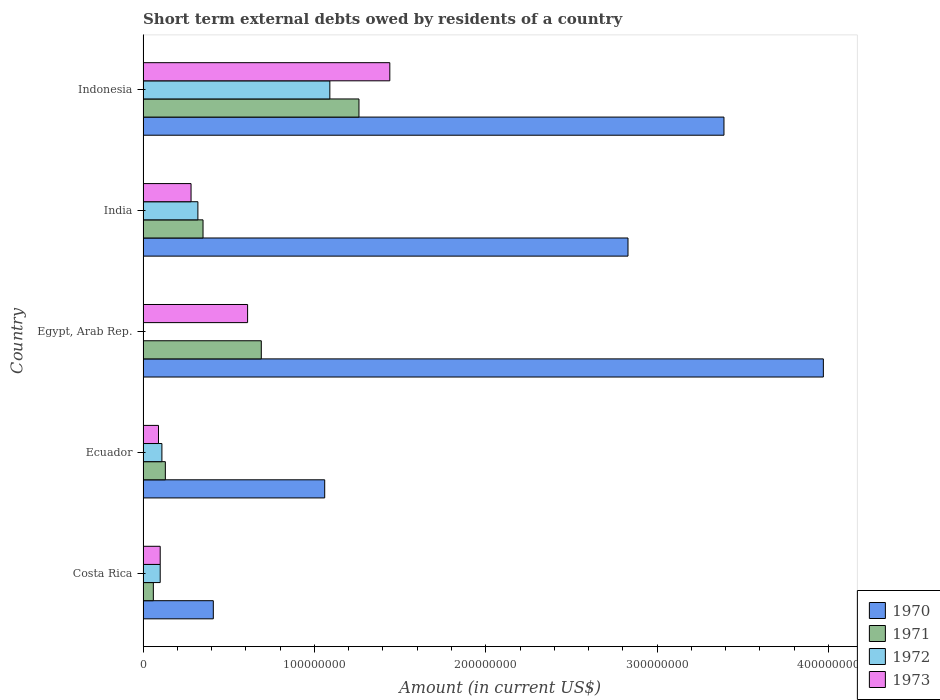How many groups of bars are there?
Offer a very short reply. 5. Are the number of bars on each tick of the Y-axis equal?
Give a very brief answer. No. How many bars are there on the 5th tick from the bottom?
Your answer should be compact. 4. What is the label of the 3rd group of bars from the top?
Ensure brevity in your answer.  Egypt, Arab Rep. What is the amount of short-term external debts owed by residents in 1973 in Egypt, Arab Rep.?
Your response must be concise. 6.10e+07. Across all countries, what is the maximum amount of short-term external debts owed by residents in 1971?
Ensure brevity in your answer.  1.26e+08. What is the total amount of short-term external debts owed by residents in 1970 in the graph?
Provide a succinct answer. 1.17e+09. What is the difference between the amount of short-term external debts owed by residents in 1972 in Costa Rica and that in Ecuador?
Provide a succinct answer. -1.00e+06. What is the difference between the amount of short-term external debts owed by residents in 1971 in India and the amount of short-term external debts owed by residents in 1972 in Ecuador?
Offer a very short reply. 2.40e+07. What is the average amount of short-term external debts owed by residents in 1970 per country?
Make the answer very short. 2.33e+08. What is the difference between the amount of short-term external debts owed by residents in 1973 and amount of short-term external debts owed by residents in 1970 in Egypt, Arab Rep.?
Offer a very short reply. -3.36e+08. In how many countries, is the amount of short-term external debts owed by residents in 1972 greater than 220000000 US$?
Your answer should be very brief. 0. What is the ratio of the amount of short-term external debts owed by residents in 1970 in Costa Rica to that in Ecuador?
Keep it short and to the point. 0.39. Is the difference between the amount of short-term external debts owed by residents in 1973 in Ecuador and India greater than the difference between the amount of short-term external debts owed by residents in 1970 in Ecuador and India?
Your answer should be compact. Yes. What is the difference between the highest and the second highest amount of short-term external debts owed by residents in 1970?
Give a very brief answer. 5.80e+07. What is the difference between the highest and the lowest amount of short-term external debts owed by residents in 1970?
Offer a terse response. 3.56e+08. In how many countries, is the amount of short-term external debts owed by residents in 1972 greater than the average amount of short-term external debts owed by residents in 1972 taken over all countries?
Give a very brief answer. 1. Is the sum of the amount of short-term external debts owed by residents in 1971 in Costa Rica and India greater than the maximum amount of short-term external debts owed by residents in 1970 across all countries?
Give a very brief answer. No. Is it the case that in every country, the sum of the amount of short-term external debts owed by residents in 1971 and amount of short-term external debts owed by residents in 1970 is greater than the sum of amount of short-term external debts owed by residents in 1972 and amount of short-term external debts owed by residents in 1973?
Give a very brief answer. No. Is it the case that in every country, the sum of the amount of short-term external debts owed by residents in 1973 and amount of short-term external debts owed by residents in 1970 is greater than the amount of short-term external debts owed by residents in 1971?
Keep it short and to the point. Yes. How many bars are there?
Your answer should be compact. 19. Are all the bars in the graph horizontal?
Your response must be concise. Yes. What is the difference between two consecutive major ticks on the X-axis?
Your answer should be very brief. 1.00e+08. Are the values on the major ticks of X-axis written in scientific E-notation?
Keep it short and to the point. No. Does the graph contain grids?
Make the answer very short. No. Where does the legend appear in the graph?
Ensure brevity in your answer.  Bottom right. How are the legend labels stacked?
Offer a very short reply. Vertical. What is the title of the graph?
Ensure brevity in your answer.  Short term external debts owed by residents of a country. What is the label or title of the Y-axis?
Your answer should be very brief. Country. What is the Amount (in current US$) of 1970 in Costa Rica?
Offer a very short reply. 4.10e+07. What is the Amount (in current US$) in 1972 in Costa Rica?
Offer a terse response. 1.00e+07. What is the Amount (in current US$) in 1970 in Ecuador?
Ensure brevity in your answer.  1.06e+08. What is the Amount (in current US$) in 1971 in Ecuador?
Your response must be concise. 1.30e+07. What is the Amount (in current US$) of 1972 in Ecuador?
Make the answer very short. 1.10e+07. What is the Amount (in current US$) of 1973 in Ecuador?
Ensure brevity in your answer.  9.00e+06. What is the Amount (in current US$) in 1970 in Egypt, Arab Rep.?
Your answer should be compact. 3.97e+08. What is the Amount (in current US$) of 1971 in Egypt, Arab Rep.?
Make the answer very short. 6.90e+07. What is the Amount (in current US$) in 1973 in Egypt, Arab Rep.?
Provide a short and direct response. 6.10e+07. What is the Amount (in current US$) in 1970 in India?
Provide a succinct answer. 2.83e+08. What is the Amount (in current US$) of 1971 in India?
Your answer should be compact. 3.50e+07. What is the Amount (in current US$) of 1972 in India?
Give a very brief answer. 3.20e+07. What is the Amount (in current US$) in 1973 in India?
Make the answer very short. 2.80e+07. What is the Amount (in current US$) of 1970 in Indonesia?
Offer a terse response. 3.39e+08. What is the Amount (in current US$) of 1971 in Indonesia?
Ensure brevity in your answer.  1.26e+08. What is the Amount (in current US$) of 1972 in Indonesia?
Your answer should be compact. 1.09e+08. What is the Amount (in current US$) in 1973 in Indonesia?
Your response must be concise. 1.44e+08. Across all countries, what is the maximum Amount (in current US$) of 1970?
Your response must be concise. 3.97e+08. Across all countries, what is the maximum Amount (in current US$) in 1971?
Provide a short and direct response. 1.26e+08. Across all countries, what is the maximum Amount (in current US$) of 1972?
Provide a succinct answer. 1.09e+08. Across all countries, what is the maximum Amount (in current US$) in 1973?
Offer a very short reply. 1.44e+08. Across all countries, what is the minimum Amount (in current US$) of 1970?
Provide a succinct answer. 4.10e+07. Across all countries, what is the minimum Amount (in current US$) of 1971?
Offer a terse response. 6.00e+06. Across all countries, what is the minimum Amount (in current US$) in 1972?
Keep it short and to the point. 0. Across all countries, what is the minimum Amount (in current US$) in 1973?
Keep it short and to the point. 9.00e+06. What is the total Amount (in current US$) in 1970 in the graph?
Your answer should be very brief. 1.17e+09. What is the total Amount (in current US$) in 1971 in the graph?
Make the answer very short. 2.49e+08. What is the total Amount (in current US$) of 1972 in the graph?
Your answer should be very brief. 1.62e+08. What is the total Amount (in current US$) in 1973 in the graph?
Your answer should be compact. 2.52e+08. What is the difference between the Amount (in current US$) in 1970 in Costa Rica and that in Ecuador?
Offer a very short reply. -6.50e+07. What is the difference between the Amount (in current US$) of 1971 in Costa Rica and that in Ecuador?
Keep it short and to the point. -7.00e+06. What is the difference between the Amount (in current US$) of 1970 in Costa Rica and that in Egypt, Arab Rep.?
Ensure brevity in your answer.  -3.56e+08. What is the difference between the Amount (in current US$) of 1971 in Costa Rica and that in Egypt, Arab Rep.?
Your response must be concise. -6.30e+07. What is the difference between the Amount (in current US$) in 1973 in Costa Rica and that in Egypt, Arab Rep.?
Give a very brief answer. -5.10e+07. What is the difference between the Amount (in current US$) in 1970 in Costa Rica and that in India?
Your answer should be compact. -2.42e+08. What is the difference between the Amount (in current US$) in 1971 in Costa Rica and that in India?
Make the answer very short. -2.90e+07. What is the difference between the Amount (in current US$) of 1972 in Costa Rica and that in India?
Make the answer very short. -2.20e+07. What is the difference between the Amount (in current US$) in 1973 in Costa Rica and that in India?
Your response must be concise. -1.80e+07. What is the difference between the Amount (in current US$) of 1970 in Costa Rica and that in Indonesia?
Provide a short and direct response. -2.98e+08. What is the difference between the Amount (in current US$) in 1971 in Costa Rica and that in Indonesia?
Give a very brief answer. -1.20e+08. What is the difference between the Amount (in current US$) in 1972 in Costa Rica and that in Indonesia?
Provide a succinct answer. -9.90e+07. What is the difference between the Amount (in current US$) of 1973 in Costa Rica and that in Indonesia?
Give a very brief answer. -1.34e+08. What is the difference between the Amount (in current US$) of 1970 in Ecuador and that in Egypt, Arab Rep.?
Make the answer very short. -2.91e+08. What is the difference between the Amount (in current US$) in 1971 in Ecuador and that in Egypt, Arab Rep.?
Provide a short and direct response. -5.60e+07. What is the difference between the Amount (in current US$) of 1973 in Ecuador and that in Egypt, Arab Rep.?
Give a very brief answer. -5.20e+07. What is the difference between the Amount (in current US$) in 1970 in Ecuador and that in India?
Give a very brief answer. -1.77e+08. What is the difference between the Amount (in current US$) of 1971 in Ecuador and that in India?
Provide a succinct answer. -2.20e+07. What is the difference between the Amount (in current US$) in 1972 in Ecuador and that in India?
Your response must be concise. -2.10e+07. What is the difference between the Amount (in current US$) of 1973 in Ecuador and that in India?
Your answer should be very brief. -1.90e+07. What is the difference between the Amount (in current US$) of 1970 in Ecuador and that in Indonesia?
Your answer should be very brief. -2.33e+08. What is the difference between the Amount (in current US$) in 1971 in Ecuador and that in Indonesia?
Your answer should be very brief. -1.13e+08. What is the difference between the Amount (in current US$) of 1972 in Ecuador and that in Indonesia?
Provide a short and direct response. -9.80e+07. What is the difference between the Amount (in current US$) in 1973 in Ecuador and that in Indonesia?
Ensure brevity in your answer.  -1.35e+08. What is the difference between the Amount (in current US$) in 1970 in Egypt, Arab Rep. and that in India?
Offer a very short reply. 1.14e+08. What is the difference between the Amount (in current US$) of 1971 in Egypt, Arab Rep. and that in India?
Your answer should be compact. 3.40e+07. What is the difference between the Amount (in current US$) of 1973 in Egypt, Arab Rep. and that in India?
Your answer should be compact. 3.30e+07. What is the difference between the Amount (in current US$) in 1970 in Egypt, Arab Rep. and that in Indonesia?
Make the answer very short. 5.80e+07. What is the difference between the Amount (in current US$) in 1971 in Egypt, Arab Rep. and that in Indonesia?
Your answer should be compact. -5.70e+07. What is the difference between the Amount (in current US$) in 1973 in Egypt, Arab Rep. and that in Indonesia?
Provide a succinct answer. -8.30e+07. What is the difference between the Amount (in current US$) in 1970 in India and that in Indonesia?
Offer a terse response. -5.60e+07. What is the difference between the Amount (in current US$) in 1971 in India and that in Indonesia?
Provide a short and direct response. -9.10e+07. What is the difference between the Amount (in current US$) in 1972 in India and that in Indonesia?
Ensure brevity in your answer.  -7.70e+07. What is the difference between the Amount (in current US$) in 1973 in India and that in Indonesia?
Provide a succinct answer. -1.16e+08. What is the difference between the Amount (in current US$) of 1970 in Costa Rica and the Amount (in current US$) of 1971 in Ecuador?
Give a very brief answer. 2.80e+07. What is the difference between the Amount (in current US$) in 1970 in Costa Rica and the Amount (in current US$) in 1972 in Ecuador?
Keep it short and to the point. 3.00e+07. What is the difference between the Amount (in current US$) of 1970 in Costa Rica and the Amount (in current US$) of 1973 in Ecuador?
Your answer should be very brief. 3.20e+07. What is the difference between the Amount (in current US$) in 1971 in Costa Rica and the Amount (in current US$) in 1972 in Ecuador?
Your answer should be compact. -5.00e+06. What is the difference between the Amount (in current US$) in 1970 in Costa Rica and the Amount (in current US$) in 1971 in Egypt, Arab Rep.?
Offer a very short reply. -2.80e+07. What is the difference between the Amount (in current US$) in 1970 in Costa Rica and the Amount (in current US$) in 1973 in Egypt, Arab Rep.?
Ensure brevity in your answer.  -2.00e+07. What is the difference between the Amount (in current US$) of 1971 in Costa Rica and the Amount (in current US$) of 1973 in Egypt, Arab Rep.?
Ensure brevity in your answer.  -5.50e+07. What is the difference between the Amount (in current US$) in 1972 in Costa Rica and the Amount (in current US$) in 1973 in Egypt, Arab Rep.?
Offer a terse response. -5.10e+07. What is the difference between the Amount (in current US$) of 1970 in Costa Rica and the Amount (in current US$) of 1972 in India?
Make the answer very short. 9.00e+06. What is the difference between the Amount (in current US$) in 1970 in Costa Rica and the Amount (in current US$) in 1973 in India?
Give a very brief answer. 1.30e+07. What is the difference between the Amount (in current US$) in 1971 in Costa Rica and the Amount (in current US$) in 1972 in India?
Provide a succinct answer. -2.60e+07. What is the difference between the Amount (in current US$) in 1971 in Costa Rica and the Amount (in current US$) in 1973 in India?
Provide a succinct answer. -2.20e+07. What is the difference between the Amount (in current US$) in 1972 in Costa Rica and the Amount (in current US$) in 1973 in India?
Your answer should be compact. -1.80e+07. What is the difference between the Amount (in current US$) of 1970 in Costa Rica and the Amount (in current US$) of 1971 in Indonesia?
Provide a short and direct response. -8.50e+07. What is the difference between the Amount (in current US$) in 1970 in Costa Rica and the Amount (in current US$) in 1972 in Indonesia?
Your response must be concise. -6.80e+07. What is the difference between the Amount (in current US$) in 1970 in Costa Rica and the Amount (in current US$) in 1973 in Indonesia?
Give a very brief answer. -1.03e+08. What is the difference between the Amount (in current US$) of 1971 in Costa Rica and the Amount (in current US$) of 1972 in Indonesia?
Ensure brevity in your answer.  -1.03e+08. What is the difference between the Amount (in current US$) in 1971 in Costa Rica and the Amount (in current US$) in 1973 in Indonesia?
Provide a short and direct response. -1.38e+08. What is the difference between the Amount (in current US$) in 1972 in Costa Rica and the Amount (in current US$) in 1973 in Indonesia?
Give a very brief answer. -1.34e+08. What is the difference between the Amount (in current US$) of 1970 in Ecuador and the Amount (in current US$) of 1971 in Egypt, Arab Rep.?
Provide a succinct answer. 3.70e+07. What is the difference between the Amount (in current US$) in 1970 in Ecuador and the Amount (in current US$) in 1973 in Egypt, Arab Rep.?
Keep it short and to the point. 4.50e+07. What is the difference between the Amount (in current US$) in 1971 in Ecuador and the Amount (in current US$) in 1973 in Egypt, Arab Rep.?
Keep it short and to the point. -4.80e+07. What is the difference between the Amount (in current US$) in 1972 in Ecuador and the Amount (in current US$) in 1973 in Egypt, Arab Rep.?
Your response must be concise. -5.00e+07. What is the difference between the Amount (in current US$) of 1970 in Ecuador and the Amount (in current US$) of 1971 in India?
Ensure brevity in your answer.  7.10e+07. What is the difference between the Amount (in current US$) in 1970 in Ecuador and the Amount (in current US$) in 1972 in India?
Keep it short and to the point. 7.40e+07. What is the difference between the Amount (in current US$) of 1970 in Ecuador and the Amount (in current US$) of 1973 in India?
Your response must be concise. 7.80e+07. What is the difference between the Amount (in current US$) in 1971 in Ecuador and the Amount (in current US$) in 1972 in India?
Make the answer very short. -1.90e+07. What is the difference between the Amount (in current US$) of 1971 in Ecuador and the Amount (in current US$) of 1973 in India?
Keep it short and to the point. -1.50e+07. What is the difference between the Amount (in current US$) of 1972 in Ecuador and the Amount (in current US$) of 1973 in India?
Your response must be concise. -1.70e+07. What is the difference between the Amount (in current US$) of 1970 in Ecuador and the Amount (in current US$) of 1971 in Indonesia?
Your answer should be very brief. -2.00e+07. What is the difference between the Amount (in current US$) of 1970 in Ecuador and the Amount (in current US$) of 1972 in Indonesia?
Keep it short and to the point. -3.00e+06. What is the difference between the Amount (in current US$) in 1970 in Ecuador and the Amount (in current US$) in 1973 in Indonesia?
Your response must be concise. -3.80e+07. What is the difference between the Amount (in current US$) in 1971 in Ecuador and the Amount (in current US$) in 1972 in Indonesia?
Provide a succinct answer. -9.60e+07. What is the difference between the Amount (in current US$) in 1971 in Ecuador and the Amount (in current US$) in 1973 in Indonesia?
Ensure brevity in your answer.  -1.31e+08. What is the difference between the Amount (in current US$) of 1972 in Ecuador and the Amount (in current US$) of 1973 in Indonesia?
Keep it short and to the point. -1.33e+08. What is the difference between the Amount (in current US$) of 1970 in Egypt, Arab Rep. and the Amount (in current US$) of 1971 in India?
Keep it short and to the point. 3.62e+08. What is the difference between the Amount (in current US$) in 1970 in Egypt, Arab Rep. and the Amount (in current US$) in 1972 in India?
Provide a short and direct response. 3.65e+08. What is the difference between the Amount (in current US$) of 1970 in Egypt, Arab Rep. and the Amount (in current US$) of 1973 in India?
Provide a succinct answer. 3.69e+08. What is the difference between the Amount (in current US$) in 1971 in Egypt, Arab Rep. and the Amount (in current US$) in 1972 in India?
Your answer should be compact. 3.70e+07. What is the difference between the Amount (in current US$) in 1971 in Egypt, Arab Rep. and the Amount (in current US$) in 1973 in India?
Provide a short and direct response. 4.10e+07. What is the difference between the Amount (in current US$) in 1970 in Egypt, Arab Rep. and the Amount (in current US$) in 1971 in Indonesia?
Your answer should be very brief. 2.71e+08. What is the difference between the Amount (in current US$) of 1970 in Egypt, Arab Rep. and the Amount (in current US$) of 1972 in Indonesia?
Offer a terse response. 2.88e+08. What is the difference between the Amount (in current US$) in 1970 in Egypt, Arab Rep. and the Amount (in current US$) in 1973 in Indonesia?
Your response must be concise. 2.53e+08. What is the difference between the Amount (in current US$) in 1971 in Egypt, Arab Rep. and the Amount (in current US$) in 1972 in Indonesia?
Your answer should be compact. -4.00e+07. What is the difference between the Amount (in current US$) in 1971 in Egypt, Arab Rep. and the Amount (in current US$) in 1973 in Indonesia?
Provide a short and direct response. -7.50e+07. What is the difference between the Amount (in current US$) of 1970 in India and the Amount (in current US$) of 1971 in Indonesia?
Provide a succinct answer. 1.57e+08. What is the difference between the Amount (in current US$) in 1970 in India and the Amount (in current US$) in 1972 in Indonesia?
Offer a terse response. 1.74e+08. What is the difference between the Amount (in current US$) of 1970 in India and the Amount (in current US$) of 1973 in Indonesia?
Make the answer very short. 1.39e+08. What is the difference between the Amount (in current US$) in 1971 in India and the Amount (in current US$) in 1972 in Indonesia?
Ensure brevity in your answer.  -7.40e+07. What is the difference between the Amount (in current US$) of 1971 in India and the Amount (in current US$) of 1973 in Indonesia?
Keep it short and to the point. -1.09e+08. What is the difference between the Amount (in current US$) in 1972 in India and the Amount (in current US$) in 1973 in Indonesia?
Provide a short and direct response. -1.12e+08. What is the average Amount (in current US$) of 1970 per country?
Keep it short and to the point. 2.33e+08. What is the average Amount (in current US$) of 1971 per country?
Make the answer very short. 4.98e+07. What is the average Amount (in current US$) in 1972 per country?
Your answer should be compact. 3.24e+07. What is the average Amount (in current US$) in 1973 per country?
Your response must be concise. 5.04e+07. What is the difference between the Amount (in current US$) of 1970 and Amount (in current US$) of 1971 in Costa Rica?
Give a very brief answer. 3.50e+07. What is the difference between the Amount (in current US$) in 1970 and Amount (in current US$) in 1972 in Costa Rica?
Offer a terse response. 3.10e+07. What is the difference between the Amount (in current US$) in 1970 and Amount (in current US$) in 1973 in Costa Rica?
Provide a short and direct response. 3.10e+07. What is the difference between the Amount (in current US$) in 1971 and Amount (in current US$) in 1973 in Costa Rica?
Your answer should be very brief. -4.00e+06. What is the difference between the Amount (in current US$) of 1970 and Amount (in current US$) of 1971 in Ecuador?
Offer a terse response. 9.30e+07. What is the difference between the Amount (in current US$) of 1970 and Amount (in current US$) of 1972 in Ecuador?
Provide a short and direct response. 9.50e+07. What is the difference between the Amount (in current US$) of 1970 and Amount (in current US$) of 1973 in Ecuador?
Give a very brief answer. 9.70e+07. What is the difference between the Amount (in current US$) in 1971 and Amount (in current US$) in 1972 in Ecuador?
Make the answer very short. 2.00e+06. What is the difference between the Amount (in current US$) of 1970 and Amount (in current US$) of 1971 in Egypt, Arab Rep.?
Offer a very short reply. 3.28e+08. What is the difference between the Amount (in current US$) in 1970 and Amount (in current US$) in 1973 in Egypt, Arab Rep.?
Give a very brief answer. 3.36e+08. What is the difference between the Amount (in current US$) of 1971 and Amount (in current US$) of 1973 in Egypt, Arab Rep.?
Your answer should be compact. 8.00e+06. What is the difference between the Amount (in current US$) in 1970 and Amount (in current US$) in 1971 in India?
Provide a short and direct response. 2.48e+08. What is the difference between the Amount (in current US$) in 1970 and Amount (in current US$) in 1972 in India?
Make the answer very short. 2.51e+08. What is the difference between the Amount (in current US$) of 1970 and Amount (in current US$) of 1973 in India?
Keep it short and to the point. 2.55e+08. What is the difference between the Amount (in current US$) of 1972 and Amount (in current US$) of 1973 in India?
Make the answer very short. 4.00e+06. What is the difference between the Amount (in current US$) in 1970 and Amount (in current US$) in 1971 in Indonesia?
Your answer should be very brief. 2.13e+08. What is the difference between the Amount (in current US$) of 1970 and Amount (in current US$) of 1972 in Indonesia?
Keep it short and to the point. 2.30e+08. What is the difference between the Amount (in current US$) of 1970 and Amount (in current US$) of 1973 in Indonesia?
Keep it short and to the point. 1.95e+08. What is the difference between the Amount (in current US$) in 1971 and Amount (in current US$) in 1972 in Indonesia?
Offer a very short reply. 1.70e+07. What is the difference between the Amount (in current US$) of 1971 and Amount (in current US$) of 1973 in Indonesia?
Provide a succinct answer. -1.80e+07. What is the difference between the Amount (in current US$) in 1972 and Amount (in current US$) in 1973 in Indonesia?
Provide a succinct answer. -3.50e+07. What is the ratio of the Amount (in current US$) in 1970 in Costa Rica to that in Ecuador?
Provide a succinct answer. 0.39. What is the ratio of the Amount (in current US$) in 1971 in Costa Rica to that in Ecuador?
Your answer should be very brief. 0.46. What is the ratio of the Amount (in current US$) in 1972 in Costa Rica to that in Ecuador?
Provide a short and direct response. 0.91. What is the ratio of the Amount (in current US$) of 1970 in Costa Rica to that in Egypt, Arab Rep.?
Make the answer very short. 0.1. What is the ratio of the Amount (in current US$) of 1971 in Costa Rica to that in Egypt, Arab Rep.?
Ensure brevity in your answer.  0.09. What is the ratio of the Amount (in current US$) in 1973 in Costa Rica to that in Egypt, Arab Rep.?
Keep it short and to the point. 0.16. What is the ratio of the Amount (in current US$) of 1970 in Costa Rica to that in India?
Offer a terse response. 0.14. What is the ratio of the Amount (in current US$) in 1971 in Costa Rica to that in India?
Offer a very short reply. 0.17. What is the ratio of the Amount (in current US$) of 1972 in Costa Rica to that in India?
Ensure brevity in your answer.  0.31. What is the ratio of the Amount (in current US$) in 1973 in Costa Rica to that in India?
Ensure brevity in your answer.  0.36. What is the ratio of the Amount (in current US$) of 1970 in Costa Rica to that in Indonesia?
Provide a succinct answer. 0.12. What is the ratio of the Amount (in current US$) in 1971 in Costa Rica to that in Indonesia?
Your response must be concise. 0.05. What is the ratio of the Amount (in current US$) in 1972 in Costa Rica to that in Indonesia?
Provide a succinct answer. 0.09. What is the ratio of the Amount (in current US$) in 1973 in Costa Rica to that in Indonesia?
Keep it short and to the point. 0.07. What is the ratio of the Amount (in current US$) of 1970 in Ecuador to that in Egypt, Arab Rep.?
Keep it short and to the point. 0.27. What is the ratio of the Amount (in current US$) in 1971 in Ecuador to that in Egypt, Arab Rep.?
Your answer should be compact. 0.19. What is the ratio of the Amount (in current US$) of 1973 in Ecuador to that in Egypt, Arab Rep.?
Provide a succinct answer. 0.15. What is the ratio of the Amount (in current US$) in 1970 in Ecuador to that in India?
Your answer should be compact. 0.37. What is the ratio of the Amount (in current US$) of 1971 in Ecuador to that in India?
Provide a succinct answer. 0.37. What is the ratio of the Amount (in current US$) in 1972 in Ecuador to that in India?
Ensure brevity in your answer.  0.34. What is the ratio of the Amount (in current US$) of 1973 in Ecuador to that in India?
Give a very brief answer. 0.32. What is the ratio of the Amount (in current US$) in 1970 in Ecuador to that in Indonesia?
Your response must be concise. 0.31. What is the ratio of the Amount (in current US$) of 1971 in Ecuador to that in Indonesia?
Provide a short and direct response. 0.1. What is the ratio of the Amount (in current US$) of 1972 in Ecuador to that in Indonesia?
Ensure brevity in your answer.  0.1. What is the ratio of the Amount (in current US$) of 1973 in Ecuador to that in Indonesia?
Your response must be concise. 0.06. What is the ratio of the Amount (in current US$) in 1970 in Egypt, Arab Rep. to that in India?
Offer a very short reply. 1.4. What is the ratio of the Amount (in current US$) of 1971 in Egypt, Arab Rep. to that in India?
Offer a terse response. 1.97. What is the ratio of the Amount (in current US$) of 1973 in Egypt, Arab Rep. to that in India?
Make the answer very short. 2.18. What is the ratio of the Amount (in current US$) of 1970 in Egypt, Arab Rep. to that in Indonesia?
Provide a short and direct response. 1.17. What is the ratio of the Amount (in current US$) in 1971 in Egypt, Arab Rep. to that in Indonesia?
Offer a very short reply. 0.55. What is the ratio of the Amount (in current US$) of 1973 in Egypt, Arab Rep. to that in Indonesia?
Keep it short and to the point. 0.42. What is the ratio of the Amount (in current US$) in 1970 in India to that in Indonesia?
Make the answer very short. 0.83. What is the ratio of the Amount (in current US$) in 1971 in India to that in Indonesia?
Your response must be concise. 0.28. What is the ratio of the Amount (in current US$) of 1972 in India to that in Indonesia?
Offer a terse response. 0.29. What is the ratio of the Amount (in current US$) in 1973 in India to that in Indonesia?
Provide a short and direct response. 0.19. What is the difference between the highest and the second highest Amount (in current US$) of 1970?
Your response must be concise. 5.80e+07. What is the difference between the highest and the second highest Amount (in current US$) in 1971?
Offer a very short reply. 5.70e+07. What is the difference between the highest and the second highest Amount (in current US$) of 1972?
Make the answer very short. 7.70e+07. What is the difference between the highest and the second highest Amount (in current US$) in 1973?
Offer a terse response. 8.30e+07. What is the difference between the highest and the lowest Amount (in current US$) of 1970?
Provide a short and direct response. 3.56e+08. What is the difference between the highest and the lowest Amount (in current US$) of 1971?
Your answer should be very brief. 1.20e+08. What is the difference between the highest and the lowest Amount (in current US$) of 1972?
Your response must be concise. 1.09e+08. What is the difference between the highest and the lowest Amount (in current US$) in 1973?
Give a very brief answer. 1.35e+08. 